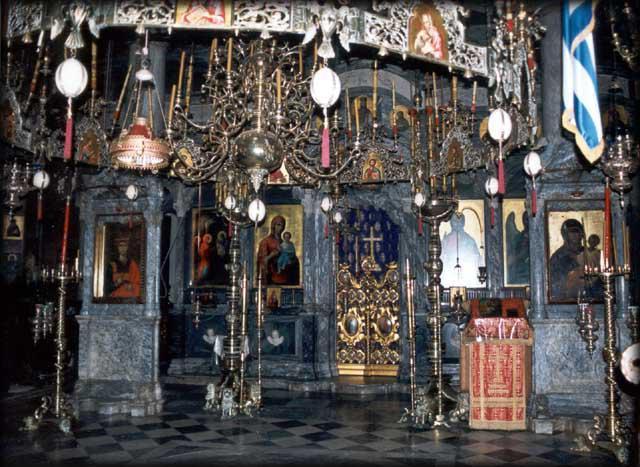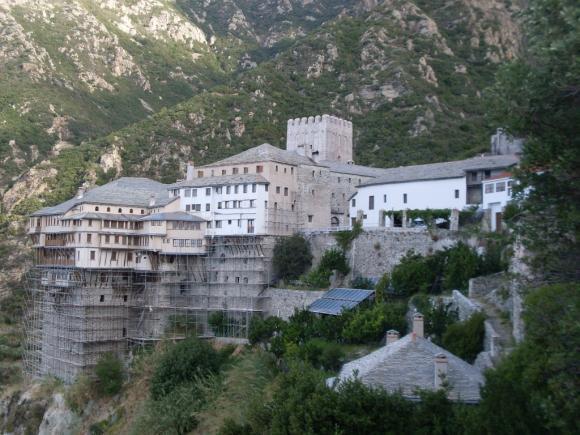The first image is the image on the left, the second image is the image on the right. For the images displayed, is the sentence "there is water in the image on the right" factually correct? Answer yes or no. No. The first image is the image on the left, the second image is the image on the right. Given the left and right images, does the statement "Only one of the images show a body of water." hold true? Answer yes or no. No. 